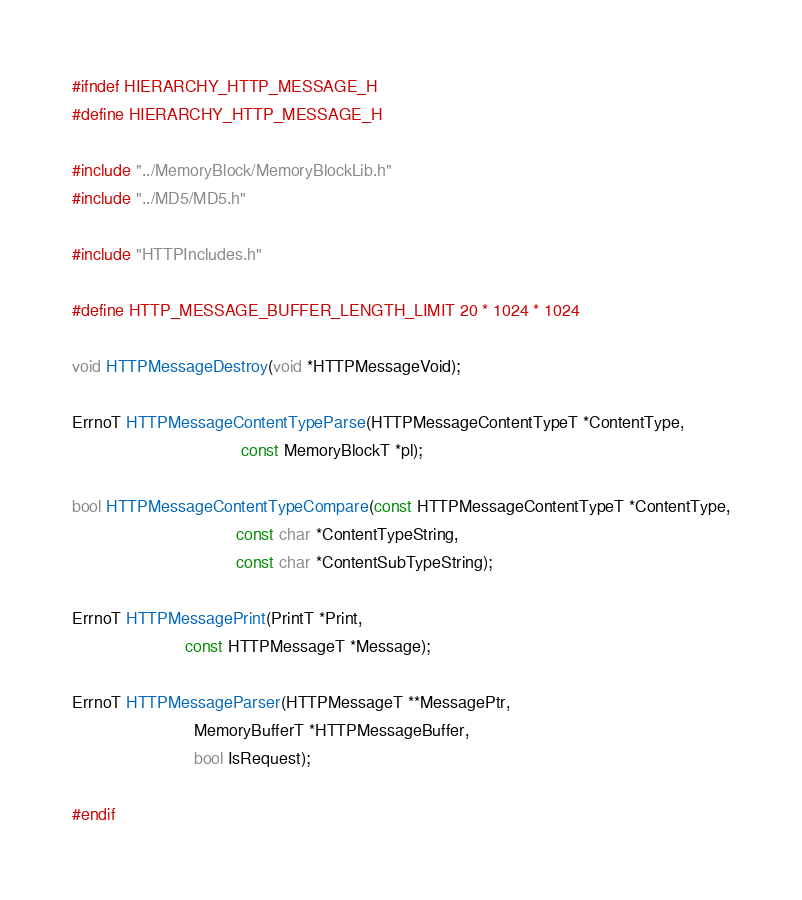<code> <loc_0><loc_0><loc_500><loc_500><_C_>#ifndef HIERARCHY_HTTP_MESSAGE_H
#define HIERARCHY_HTTP_MESSAGE_H

#include "../MemoryBlock/MemoryBlockLib.h"
#include "../MD5/MD5.h"

#include "HTTPIncludes.h"

#define HTTP_MESSAGE_BUFFER_LENGTH_LIMIT 20 * 1024 * 1024

void HTTPMessageDestroy(void *HTTPMessageVoid);

ErrnoT HTTPMessageContentTypeParse(HTTPMessageContentTypeT *ContentType,
                                    const MemoryBlockT *pl);

bool HTTPMessageContentTypeCompare(const HTTPMessageContentTypeT *ContentType,
                                   const char *ContentTypeString,
                                   const char *ContentSubTypeString);

ErrnoT HTTPMessagePrint(PrintT *Print,
                        const HTTPMessageT *Message);

ErrnoT HTTPMessageParser(HTTPMessageT **MessagePtr,
                          MemoryBufferT *HTTPMessageBuffer,
                          bool IsRequest);

#endif
</code> 